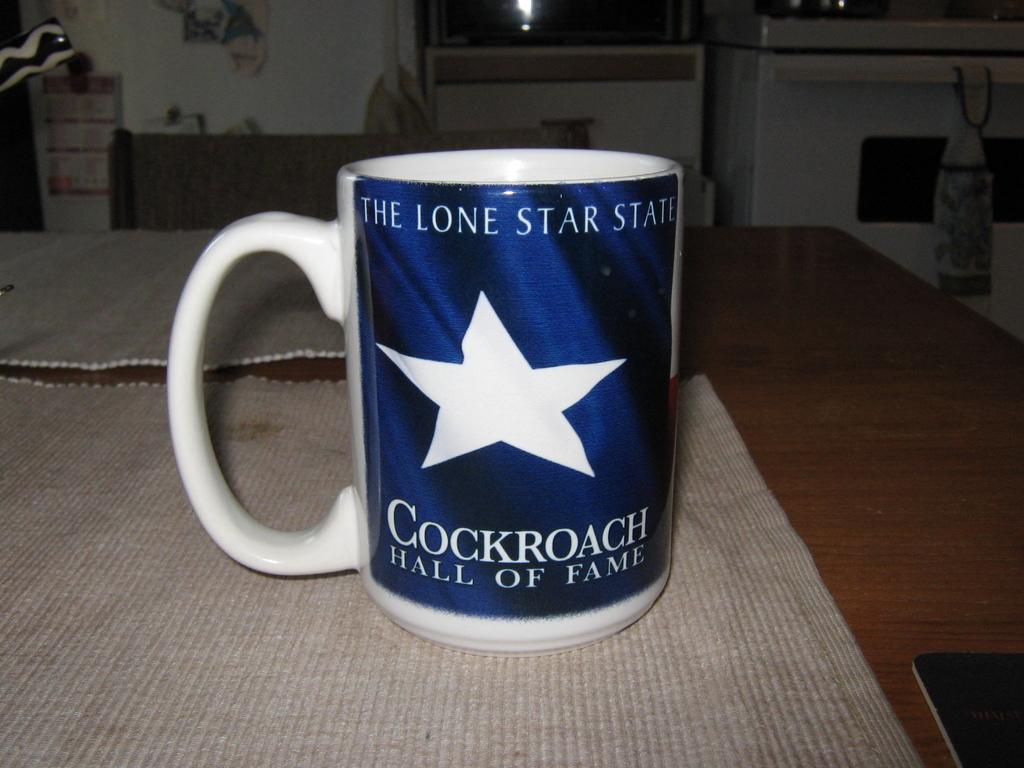What is the word under the star?
Offer a terse response. Cockroach. What colour is the banner?
Provide a short and direct response. Answering does not require reading text in the image. 